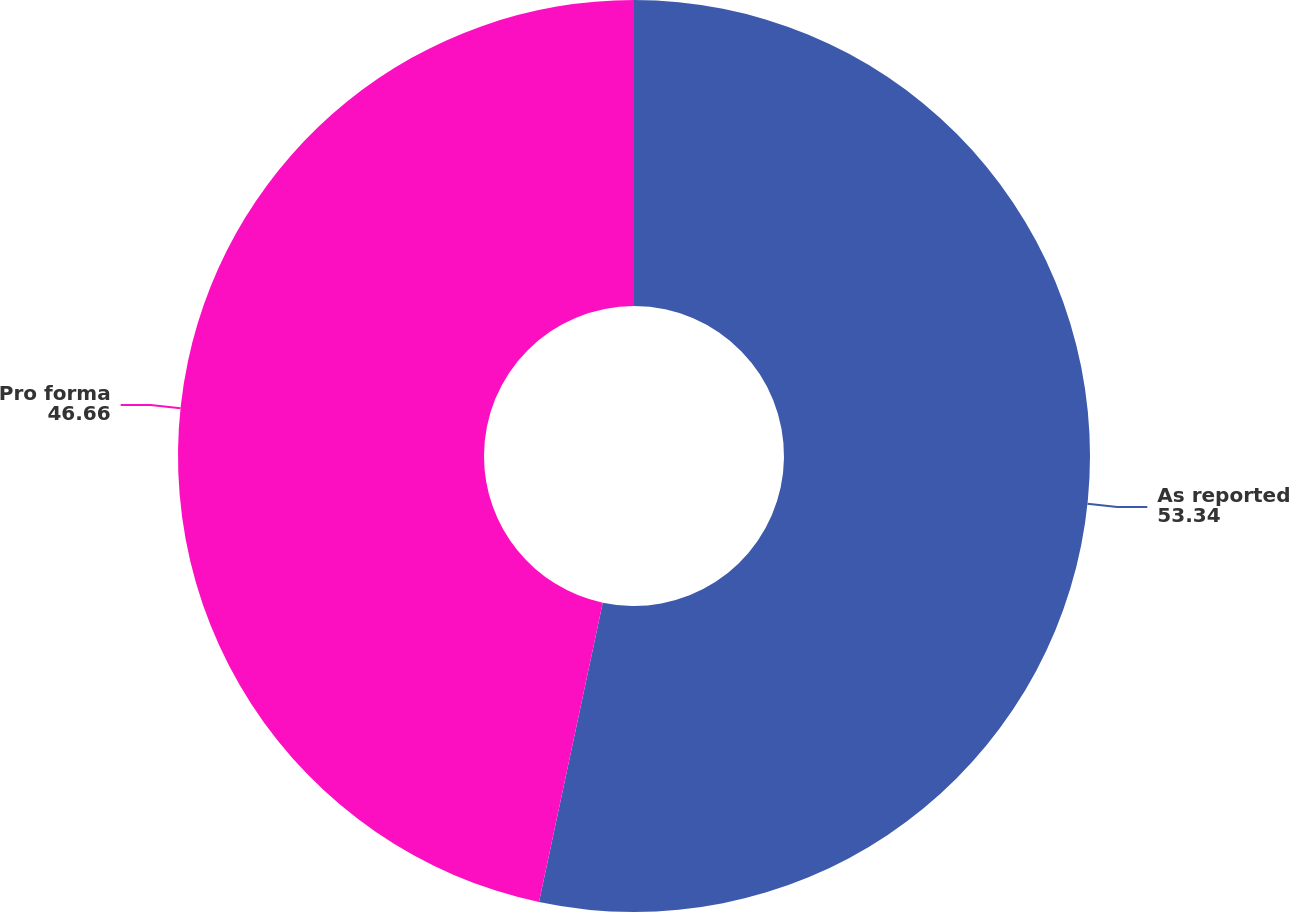Convert chart to OTSL. <chart><loc_0><loc_0><loc_500><loc_500><pie_chart><fcel>As reported<fcel>Pro forma<nl><fcel>53.34%<fcel>46.66%<nl></chart> 